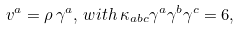<formula> <loc_0><loc_0><loc_500><loc_500>v ^ { a } = \rho \, \gamma ^ { a } , \, w i t h \, \kappa _ { a b c } \gamma ^ { a } \gamma ^ { b } \gamma ^ { c } = 6 ,</formula> 